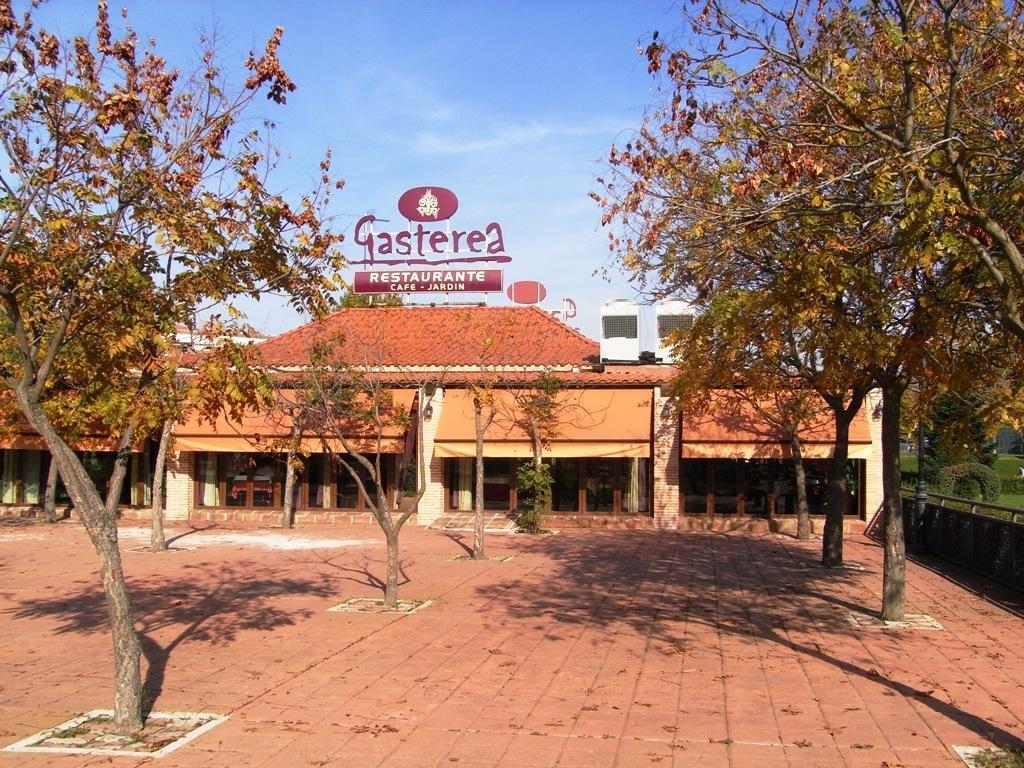Describe this image in one or two sentences. In this image I can see trees. In the background I can see a building and the sky. On the right side I can see fence, a pole and the grass. 